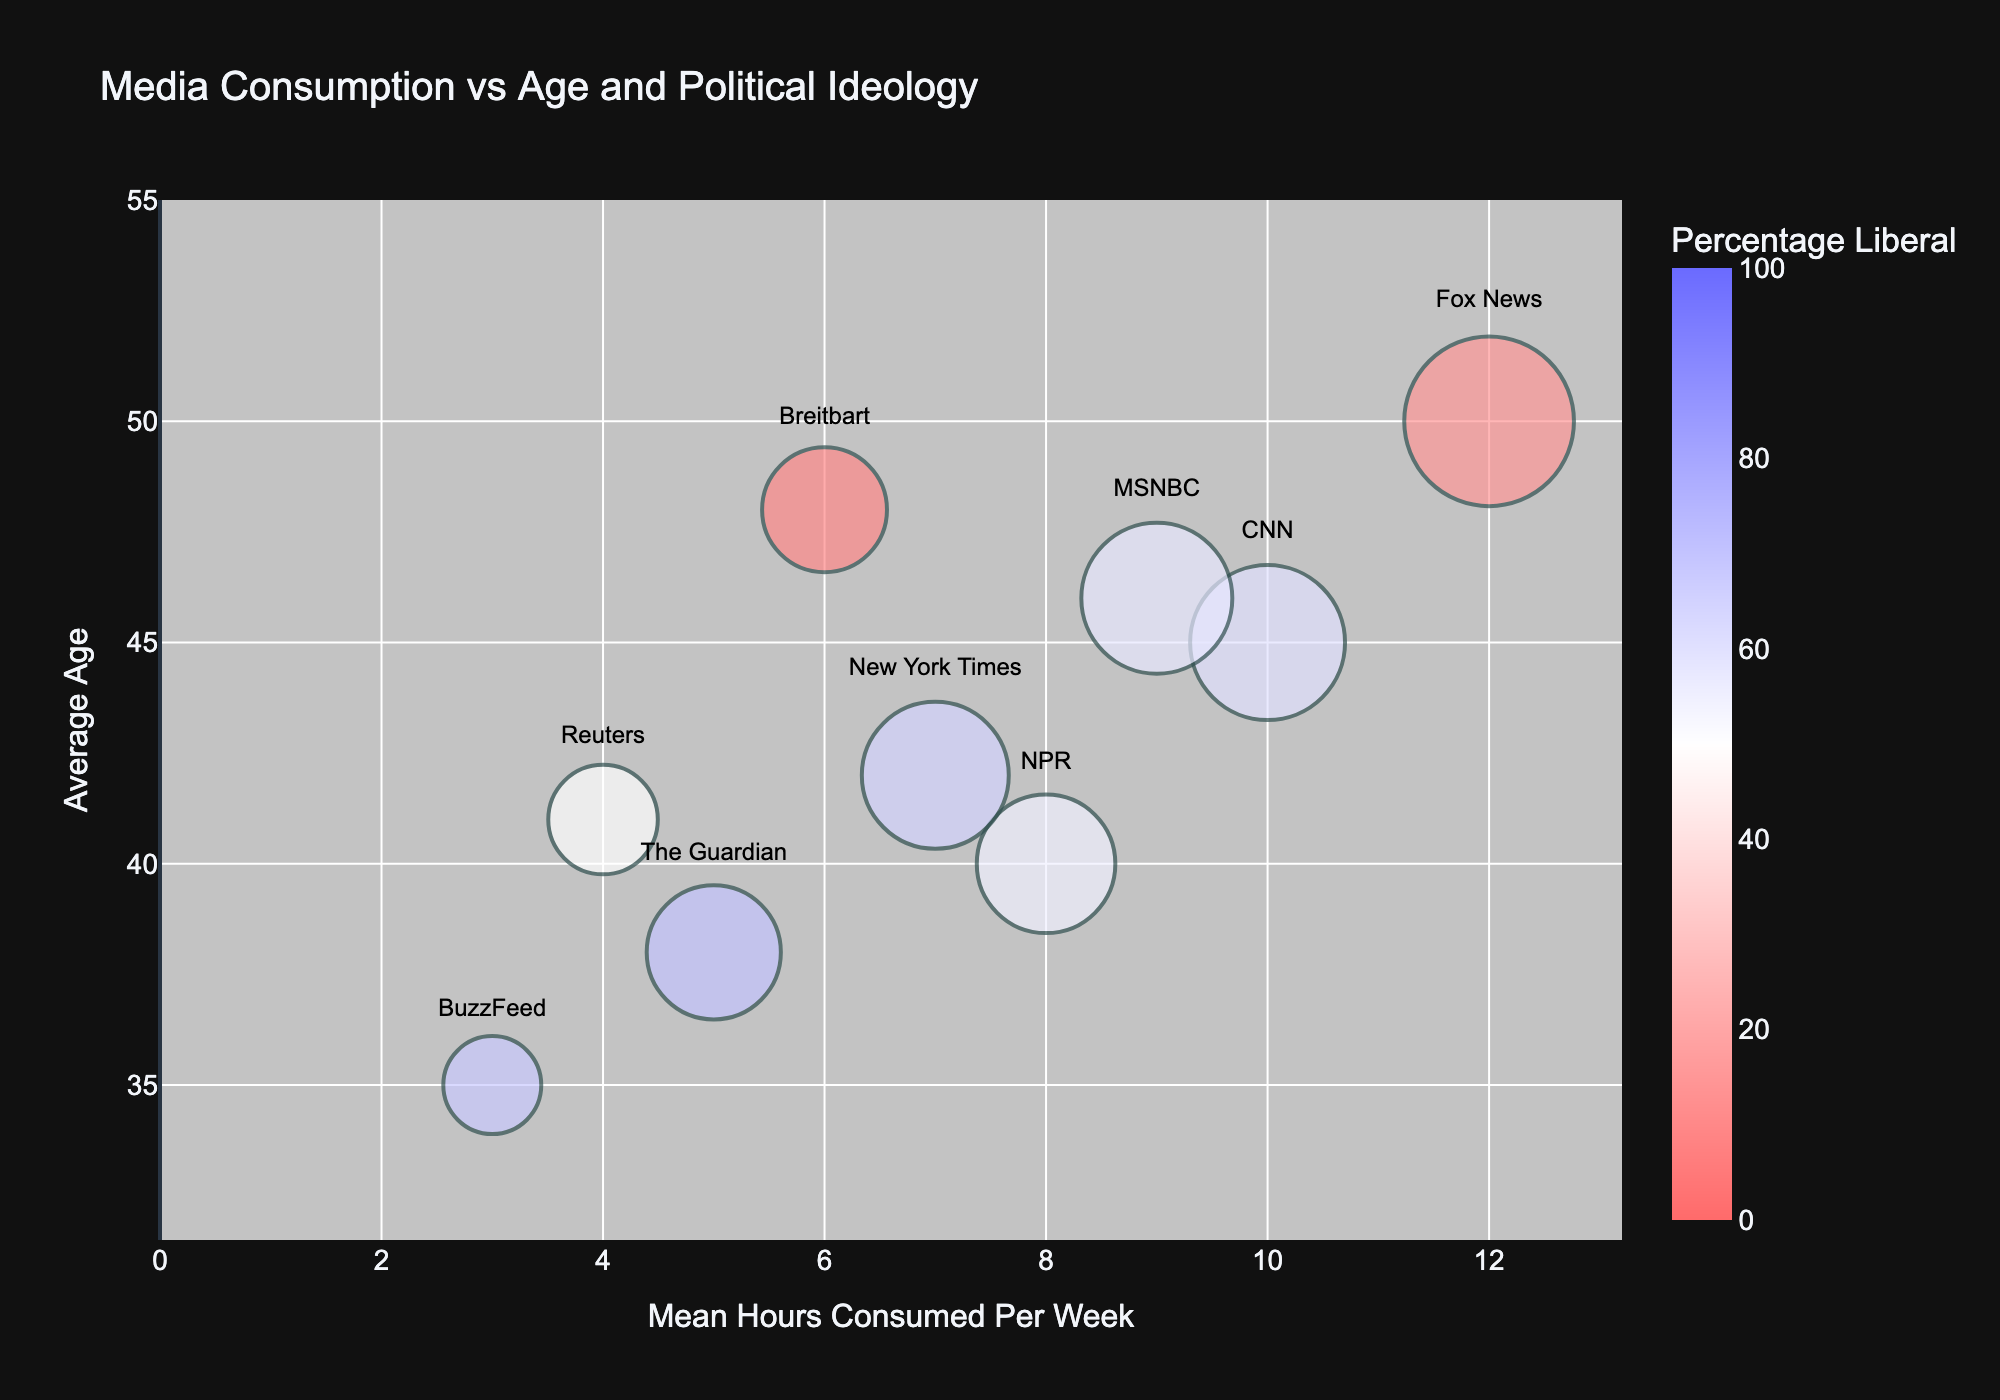What is the title of the bubble chart? The title appears at the top of the chart, which helps to quickly understand its focus.
Answer: Media Consumption vs Age and Political Ideology Which media source has the largest bubble? The largest bubble will visually appear bigger than the others. By a quick glance, you can see that Fox News has the largest bubble, indicating the highest number of viewers or significance.
Answer: Fox News What is the mean number of hours consumed per week for the media source with the youngest average age? Identify the bubble representing the youngest age first, then look for its corresponding mean hours consumed per week. BuzzFeed, with an average age of 35, has a mean of 3 hours.
Answer: 3 hours Which media source is closest to 50% liberal in terms of percentage? Locate the bubble color closest to the middle of the color scale (as the scale goes from 0 to 100). Reuters at 50% matches this criteria.
Answer: Reuters Which media source has a higher percentage of conservatives, Breitbart or Fox News? Compare the colors of the bubbles for these two media sources. Fox News is at 70%; Breitbart is at 75%.
Answer: Breitbart How many media sources have a mean number of hours consumed per week greater than 8? Visually inspect the x-axis and count the bubbles located to the right of the value 8. Three sources are located beyond 8 hours: CNN, Fox News, and MSNBC.
Answer: 3 What is the average age for media sources with more than 50% liberal viewership? Isolate the bubbles colored to indicate +50% liberals, then calculate the average: CNN (45), NPR (40), New York Times (42), MSNBC (46), Guardian (38), BuzzFeed (35). The average is (45 + 40 + 42 + 46 + 38 + 35) / 6 = 41.
Answer: 41 Which media source represents the smallest bubble? Identify visually the smallest bubble, which is BuzzFeed with a bubble size of 40.
Answer: BuzzFeed Considering both the y-axis (average age) and the x-axis (mean hours consumed per week), which media source targets an older audience while having a lower mean number of hours consumed? Focus on bubbles in the upper left quadrant (high average age, low mean hours). Breitbart with an average age of 48 and 6 mean hours.
Answer: Breitbart What is the overall trend in political ideology (percentage liberal) related to the average age of media sources? Analyze the color gradient of bubbles as the position along the y-axis (average age) changes. Older audiences seem to have a lower liberal percentage (darker blue), whereas younger audiences spike in higher liberal percentages (lighter colors).
Answer: Younger audiences are more liberal 